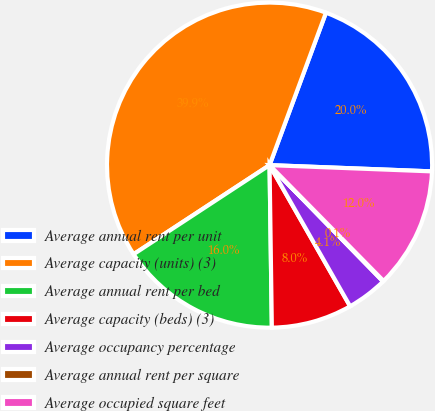Convert chart. <chart><loc_0><loc_0><loc_500><loc_500><pie_chart><fcel>Average annual rent per unit<fcel>Average capacity (units) (3)<fcel>Average annual rent per bed<fcel>Average capacity (beds) (3)<fcel>Average occupancy percentage<fcel>Average annual rent per square<fcel>Average occupied square feet<nl><fcel>19.97%<fcel>39.87%<fcel>15.99%<fcel>8.03%<fcel>4.05%<fcel>0.07%<fcel>12.01%<nl></chart> 